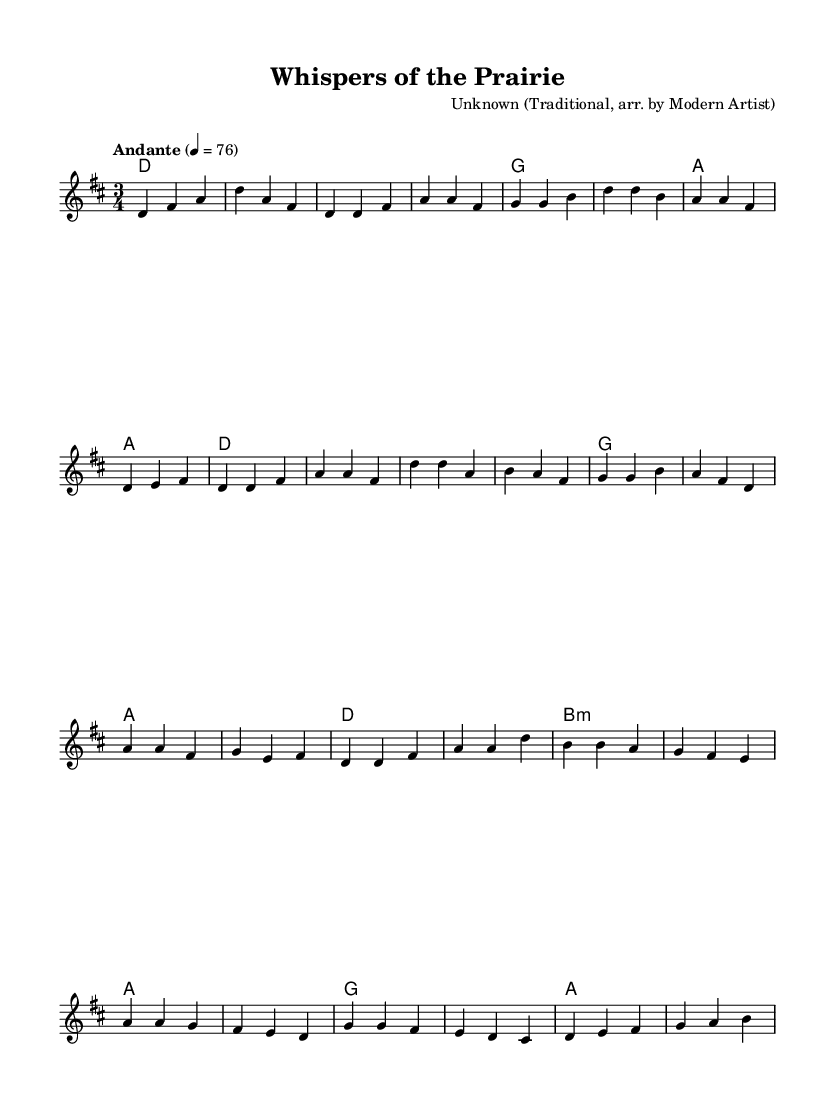What is the key signature of this music? The key signature is D major, as indicated by the two sharps (F# and C#) shown in the key signature section at the beginning of the score.
Answer: D major What is the time signature of this piece? The time signature is 3/4, which is represented after the key signature and indicates that there are three beats in each measure.
Answer: 3/4 What tempo is indicated for the music? The tempo marking is "Andante" with a metronome marking of 76, which instructs the performer to play at a moderately slow pace.
Answer: Andante 4 = 76 How many verses are present in the song structure? By examining the melody section, it's clear that it follows a verse-chorus format, and there are two identified portions labeled for verses.
Answer: 1 What chord is played during the bridge section? In the bridge, the first chord listed is B minor, as shown in the harmonies section; this provides the harmonic context for that part of the song.
Answer: B minor What is the predominant musical style reflected in this piece? The song is characterized by a folk-inspired approach emphasized through storytelling and a narrative structure, typical for folk music.
Answer: Folk 